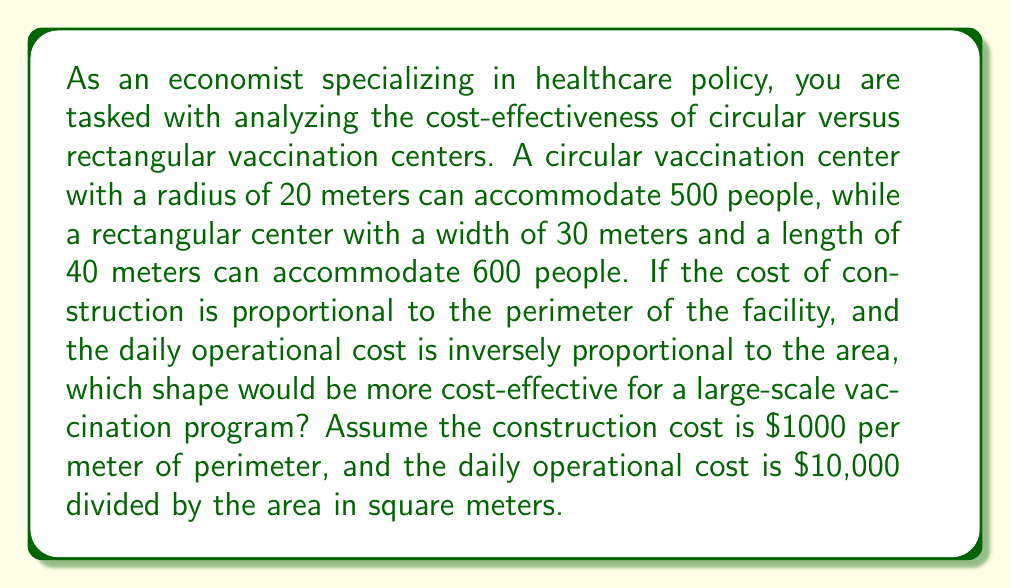Could you help me with this problem? To determine the most cost-effective shape, we need to calculate and compare the total costs for both the circular and rectangular vaccination centers. We'll do this in several steps:

1. Calculate the perimeter and area of each shape:

Circular center:
$$\text{Radius} = 20\text{ m}$$
$$\text{Perimeter} = 2\pi r = 2\pi(20) \approx 125.66\text{ m}$$
$$\text{Area} = \pi r^2 = \pi(20^2) \approx 1256.64\text{ m}^2$$

Rectangular center:
$$\text{Width} = 30\text{ m}, \text{Length} = 40\text{ m}$$
$$\text{Perimeter} = 2(w + l) = 2(30 + 40) = 140\text{ m}$$
$$\text{Area} = w \times l = 30 \times 40 = 1200\text{ m}^2$$

2. Calculate the construction costs:

Circular center:
$$\text{Construction cost} = 1000 \times 125.66 = \$125,660$$

Rectangular center:
$$\text{Construction cost} = 1000 \times 140 = \$140,000$$

3. Calculate the daily operational costs:

Circular center:
$$\text{Operational cost} = \frac{10,000}{1256.64} \approx \$7.96\text{ per day}$$

Rectangular center:
$$\text{Operational cost} = \frac{10,000}{1200} \approx \$8.33\text{ per day}$$

4. Calculate the cost per person accommodated:

Circular center:
$$\text{Cost per person} = \frac{125,660}{500} = \$251.32$$

Rectangular center:
$$\text{Cost per person} = \frac{140,000}{600} \approx \$233.33$$

5. Compare long-term costs:

To find the break-even point where the circular center becomes more cost-effective, we can set up an equation:

$$125,660 + 7.96x = 140,000 + 8.33x$$
$$-14,340 = 0.37x$$
$$x \approx 38,756\text{ days} \approx 106\text{ years}$$

Where $x$ is the number of days of operation.
Answer: The rectangular vaccination center is more cost-effective for a large-scale vaccination program. It has a lower initial cost per person accommodated ($233.33 vs. $251.32) and would take approximately 106 years of daily operation for the circular center to become more cost-effective due to its slightly lower daily operational cost. Given that vaccination programs typically don't run for such extended periods, the rectangular shape is the more economical choice in this scenario. 